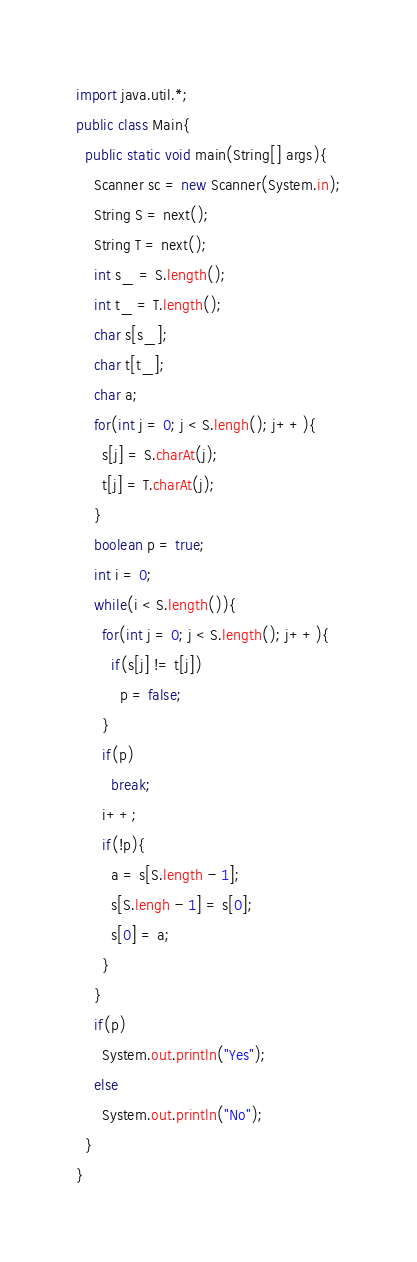Convert code to text. <code><loc_0><loc_0><loc_500><loc_500><_Java_>import java.util.*;
public class Main{
  public static void main(String[] args){
    Scanner sc = new Scanner(System.in);
    String S = next();
    String T = next();
    int s_ = S.length();
    int t_ = T.length();
    char s[s_];
    char t[t_];
    char a;
    for(int j = 0; j < S.lengh(); j++){
      s[j] = S.charAt(j);
      t[j] = T.charAt(j);
    }
    boolean p = true;
    int i = 0;
    while(i < S.length()){
      for(int j = 0; j < S.length(); j++){
        if(s[j] != t[j])
          p = false;
      }
      if(p)
        break;
      i++;
      if(!p){
        a = s[S.length - 1];
        s[S.lengh - 1] = s[0];
        s[0] = a;
      }
    }
    if(p)
      System.out.println("Yes");
    else
      System.out.println("No");
  }
}      
</code> 